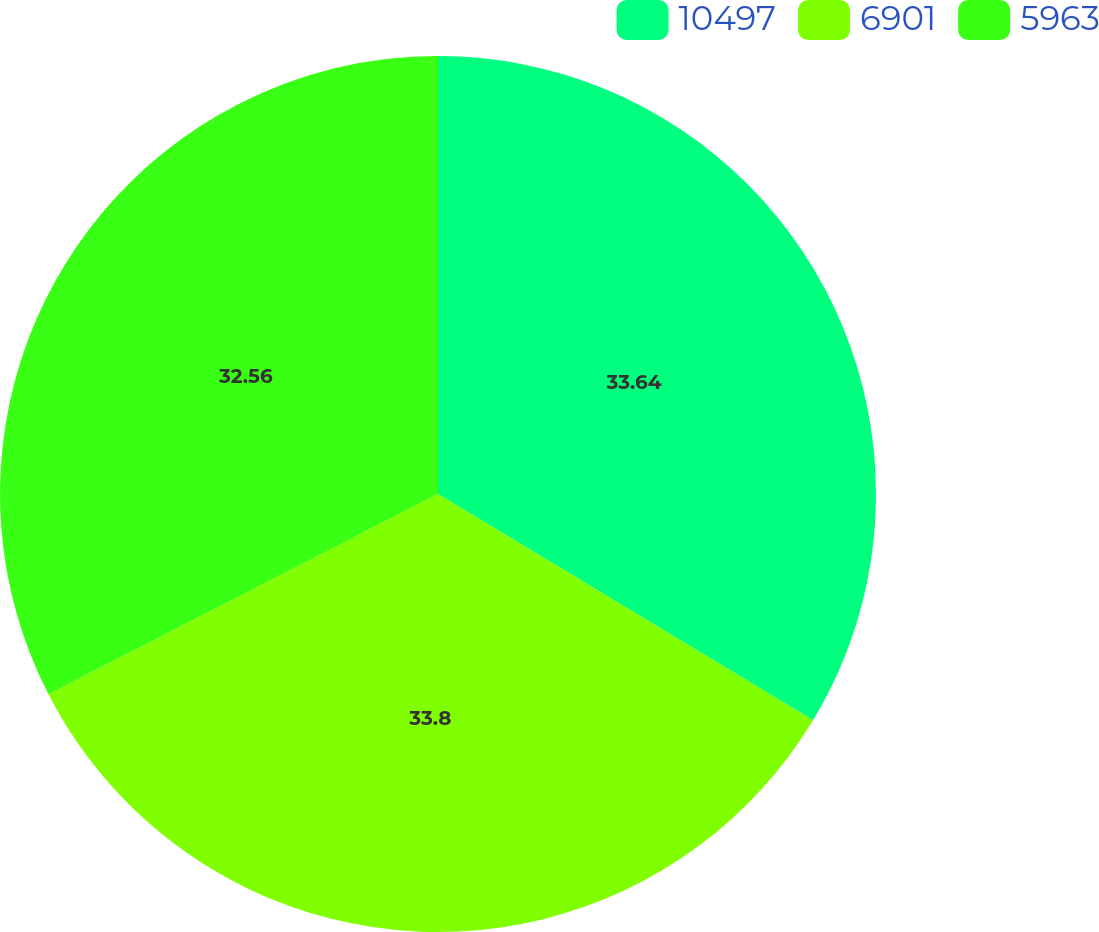Convert chart to OTSL. <chart><loc_0><loc_0><loc_500><loc_500><pie_chart><fcel>10497<fcel>6901<fcel>5963<nl><fcel>33.64%<fcel>33.8%<fcel>32.56%<nl></chart> 